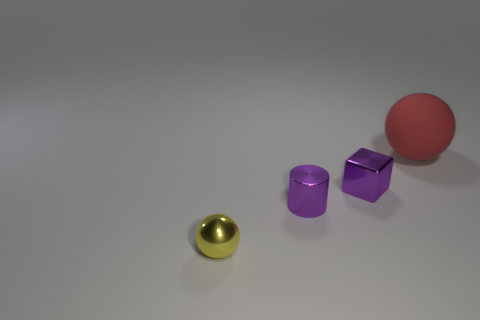Could the lighting in the scene tell us anything about the environment? Yes, the shadows and highlights on the objects suggest a soft, diffused light source, likely from above. This could indicate an indoor setting with ambient lighting, and the fact that there are no harsh shadows or bright highlights means the lighting is well balanced, which is often desired in product rendering or design settings. 